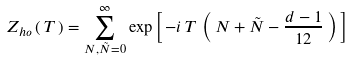Convert formula to latex. <formula><loc_0><loc_0><loc_500><loc_500>Z _ { h o } \left ( \, T \, \right ) = \sum _ { N , \tilde { N } = 0 } ^ { \infty } \exp \left [ \, - i \, T \, \left ( \, N + \tilde { N } - \frac { d - 1 } { 1 2 } \, \right ) \, \right ]</formula> 